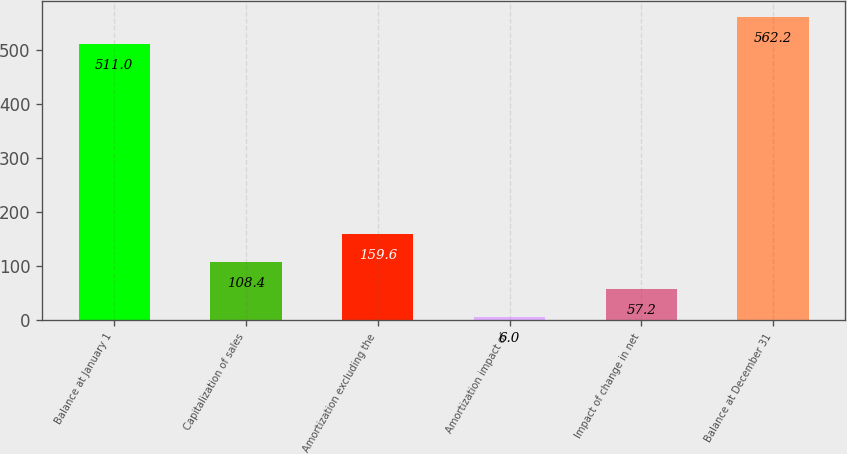Convert chart. <chart><loc_0><loc_0><loc_500><loc_500><bar_chart><fcel>Balance at January 1<fcel>Capitalization of sales<fcel>Amortization excluding the<fcel>Amortization impact of<fcel>Impact of change in net<fcel>Balance at December 31<nl><fcel>511<fcel>108.4<fcel>159.6<fcel>6<fcel>57.2<fcel>562.2<nl></chart> 